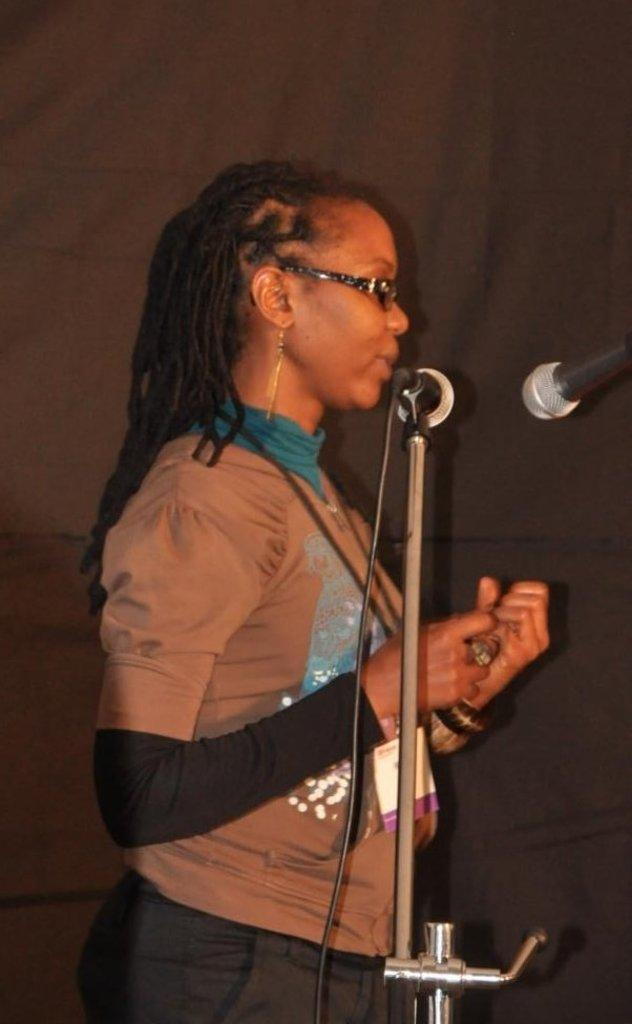What is the main subject of the image? There is a woman standing in the image. What objects are on the right side of the image? There are two microphones on the right side of the image. What can be seen in the background of the image? There is a curtain visible in the background of the image. What type of car is being designed in the image? There is no car or design process present in the image. What type of voyage is the woman embarking on in the image? There is no indication of a voyage or any travel-related activity in the image. 